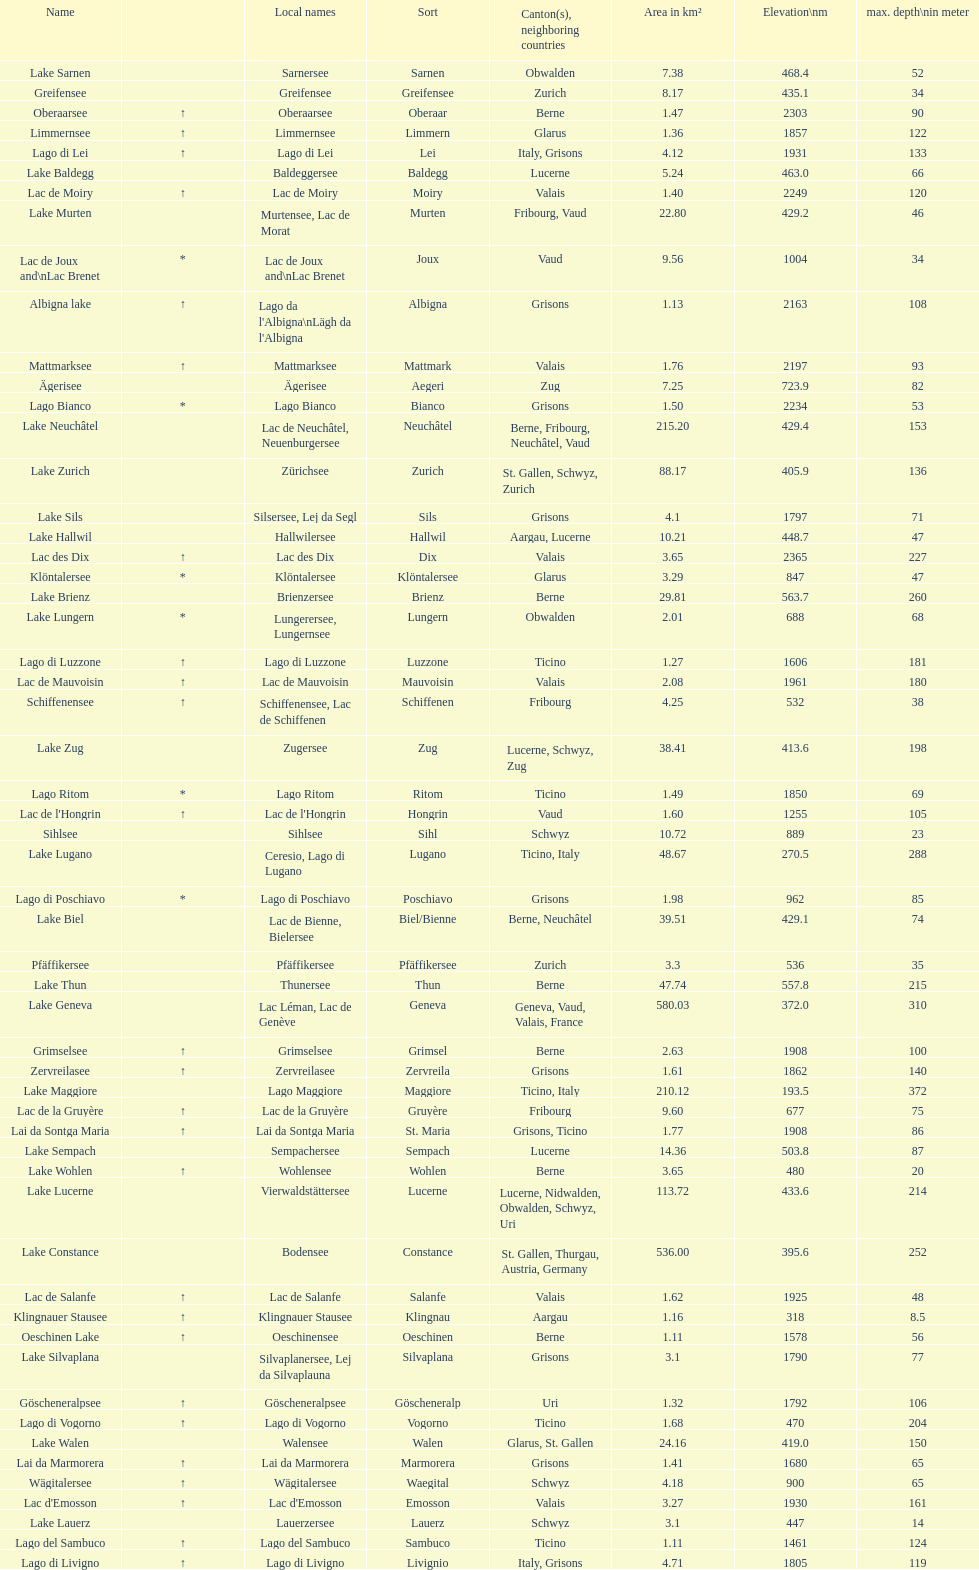What's the total max depth of lake geneva and lake constance combined? 562. 